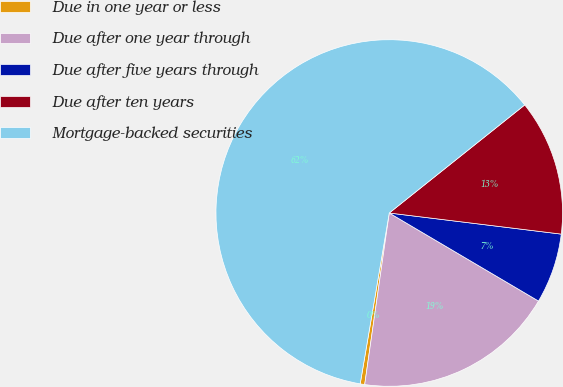Convert chart. <chart><loc_0><loc_0><loc_500><loc_500><pie_chart><fcel>Due in one year or less<fcel>Due after one year through<fcel>Due after five years through<fcel>Due after ten years<fcel>Mortgage-backed securities<nl><fcel>0.42%<fcel>18.78%<fcel>6.54%<fcel>12.66%<fcel>61.6%<nl></chart> 